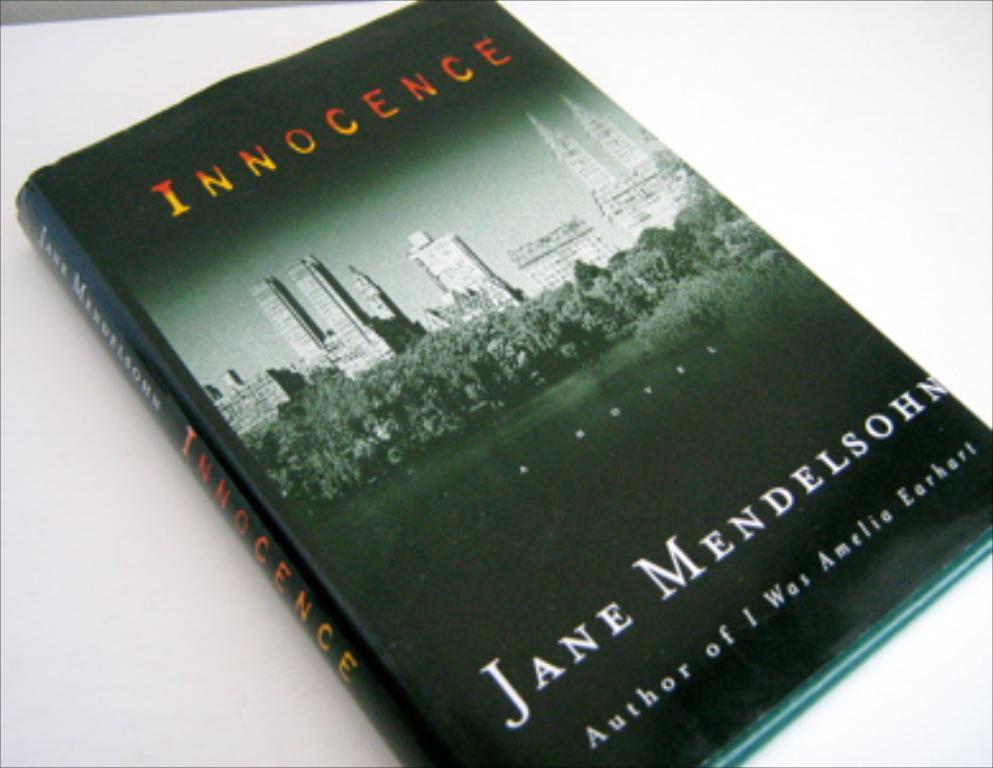Who who this book?
Keep it short and to the point. Jane mendelsohn. 